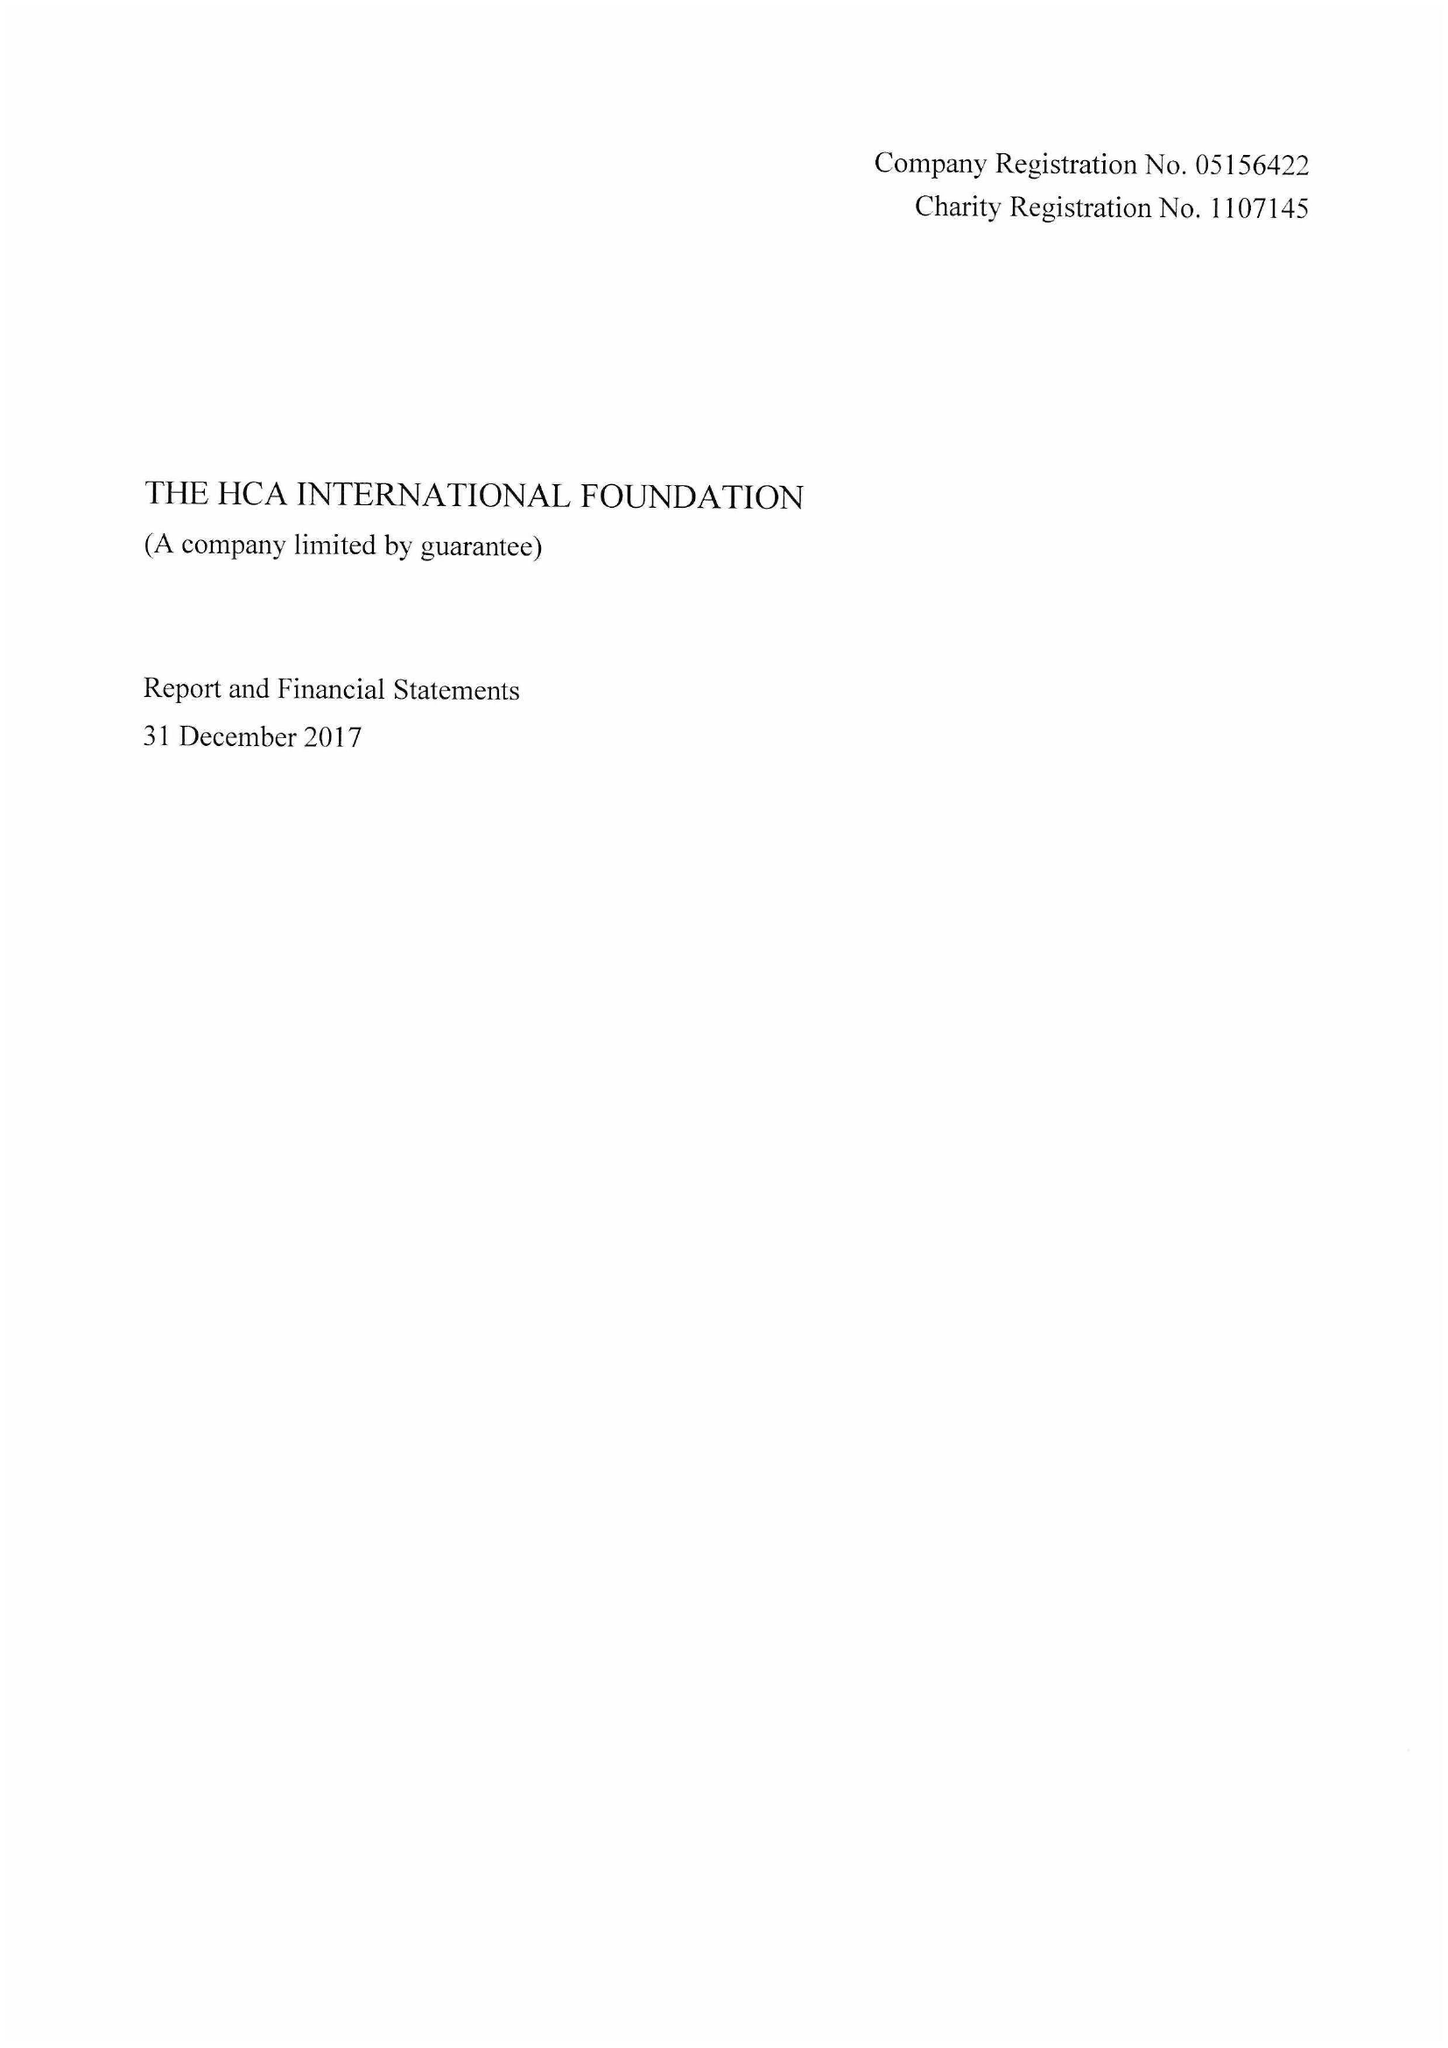What is the value for the address__post_town?
Answer the question using a single word or phrase. LONDON 